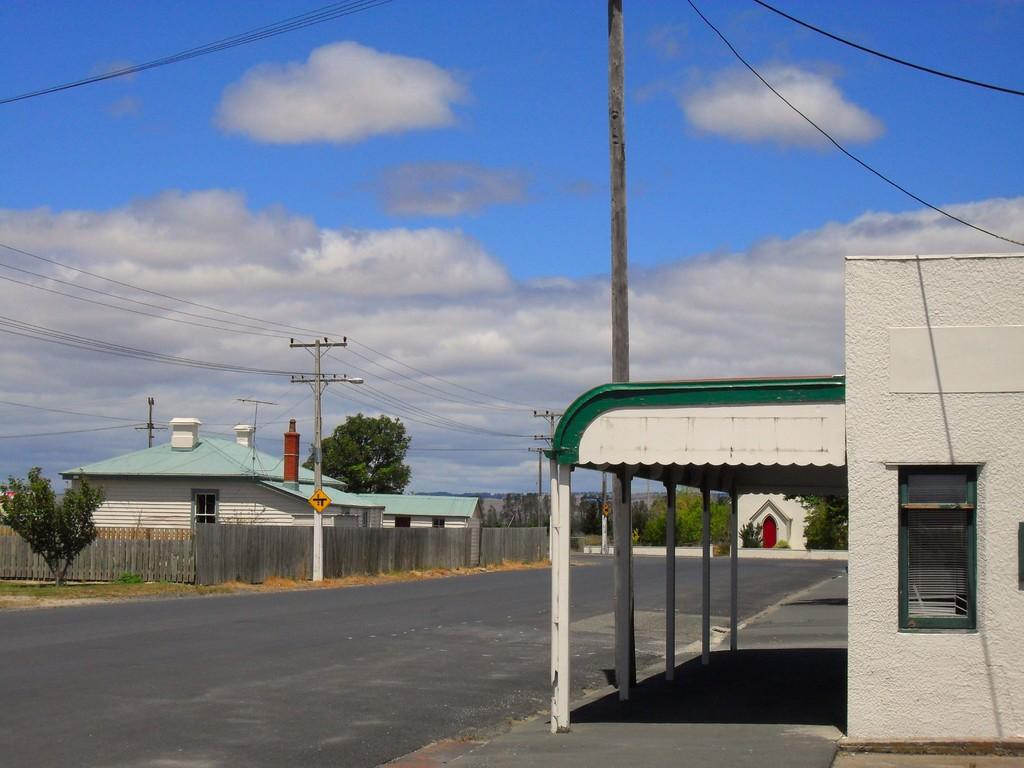What type of pathway is visible in the image? There is a road in the image. What type of structures can be seen along the road? There are houses in the image. What type of vegetation is present in the image? There is a tree and a plant in the image. What type of man-made object is present in the image? There is a pole in the image. What type of utility infrastructure is present in the image? There are wires in the image. What type of lighting fixture is present in the image? There is a street light in the image. What type of natural phenomenon can be seen in the sky in the image? There are clouds in the sky in the image. How many corn stalks are visible in the image? There is no corn visible in the image. What type of creatures are crawling on the tree in the image? There are no spiders or any other creatures visible on the tree in the image. 